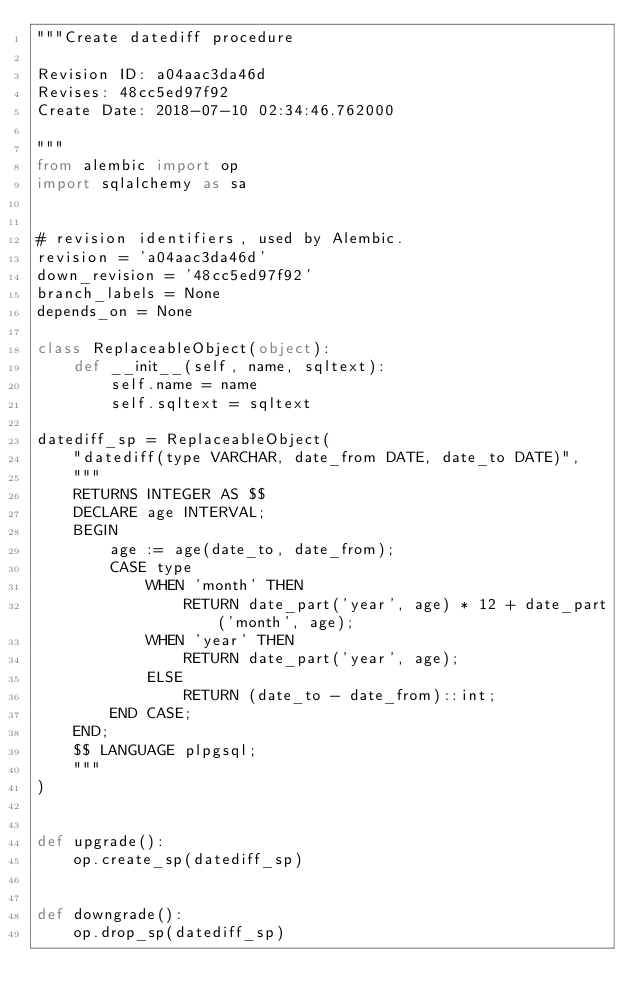<code> <loc_0><loc_0><loc_500><loc_500><_Python_>"""Create datediff procedure

Revision ID: a04aac3da46d
Revises: 48cc5ed97f92
Create Date: 2018-07-10 02:34:46.762000

"""
from alembic import op
import sqlalchemy as sa


# revision identifiers, used by Alembic.
revision = 'a04aac3da46d'
down_revision = '48cc5ed97f92'
branch_labels = None
depends_on = None

class ReplaceableObject(object):
    def __init__(self, name, sqltext):
        self.name = name
        self.sqltext = sqltext

datediff_sp = ReplaceableObject(
    "datediff(type VARCHAR, date_from DATE, date_to DATE)",
    """
    RETURNS INTEGER AS $$
    DECLARE age INTERVAL;
    BEGIN
        age := age(date_to, date_from);
        CASE type
            WHEN 'month' THEN
                RETURN date_part('year', age) * 12 + date_part('month', age);
            WHEN 'year' THEN
                RETURN date_part('year', age);
            ELSE
                RETURN (date_to - date_from)::int;
        END CASE;
    END;
    $$ LANGUAGE plpgsql;
    """
)


def upgrade():
    op.create_sp(datediff_sp)


def downgrade():
    op.drop_sp(datediff_sp)
</code> 